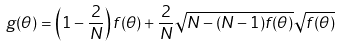<formula> <loc_0><loc_0><loc_500><loc_500>g ( \theta ) = \left ( 1 - \frac { 2 } { N } \right ) f ( \theta ) + \frac { 2 } { N } \sqrt { N - ( N - 1 ) f ( \theta ) } \sqrt { f ( \theta ) }</formula> 